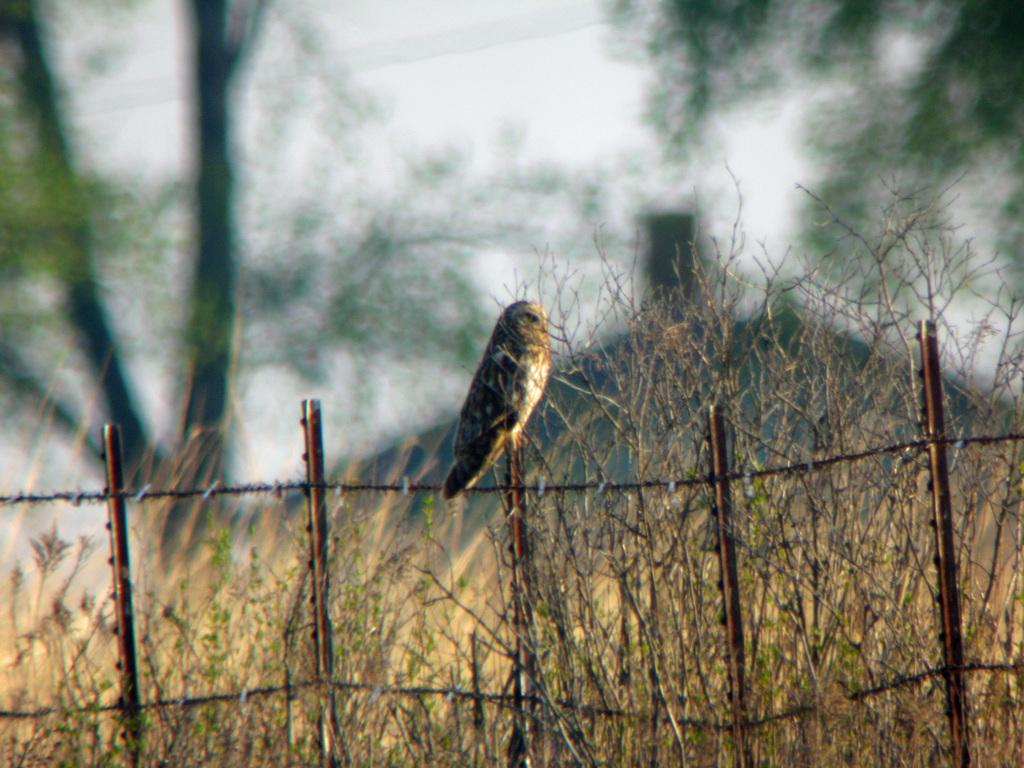What is located in the center of the image? There is a fence in the center of the image. What can be seen near the fence? There are plants near the fence. What is the bird doing in the image? A bird is perched on the fence. What is visible in the background of the image? There are trees visible in the background. How would you describe the appearance of the background? The background appears blurred. What type of roof can be seen on the building in the image? There is no building or roof present in the image; it features a fence, plants, a bird, trees, and a blurred background. How many faces are visible in the image? There are no faces visible in the image. 